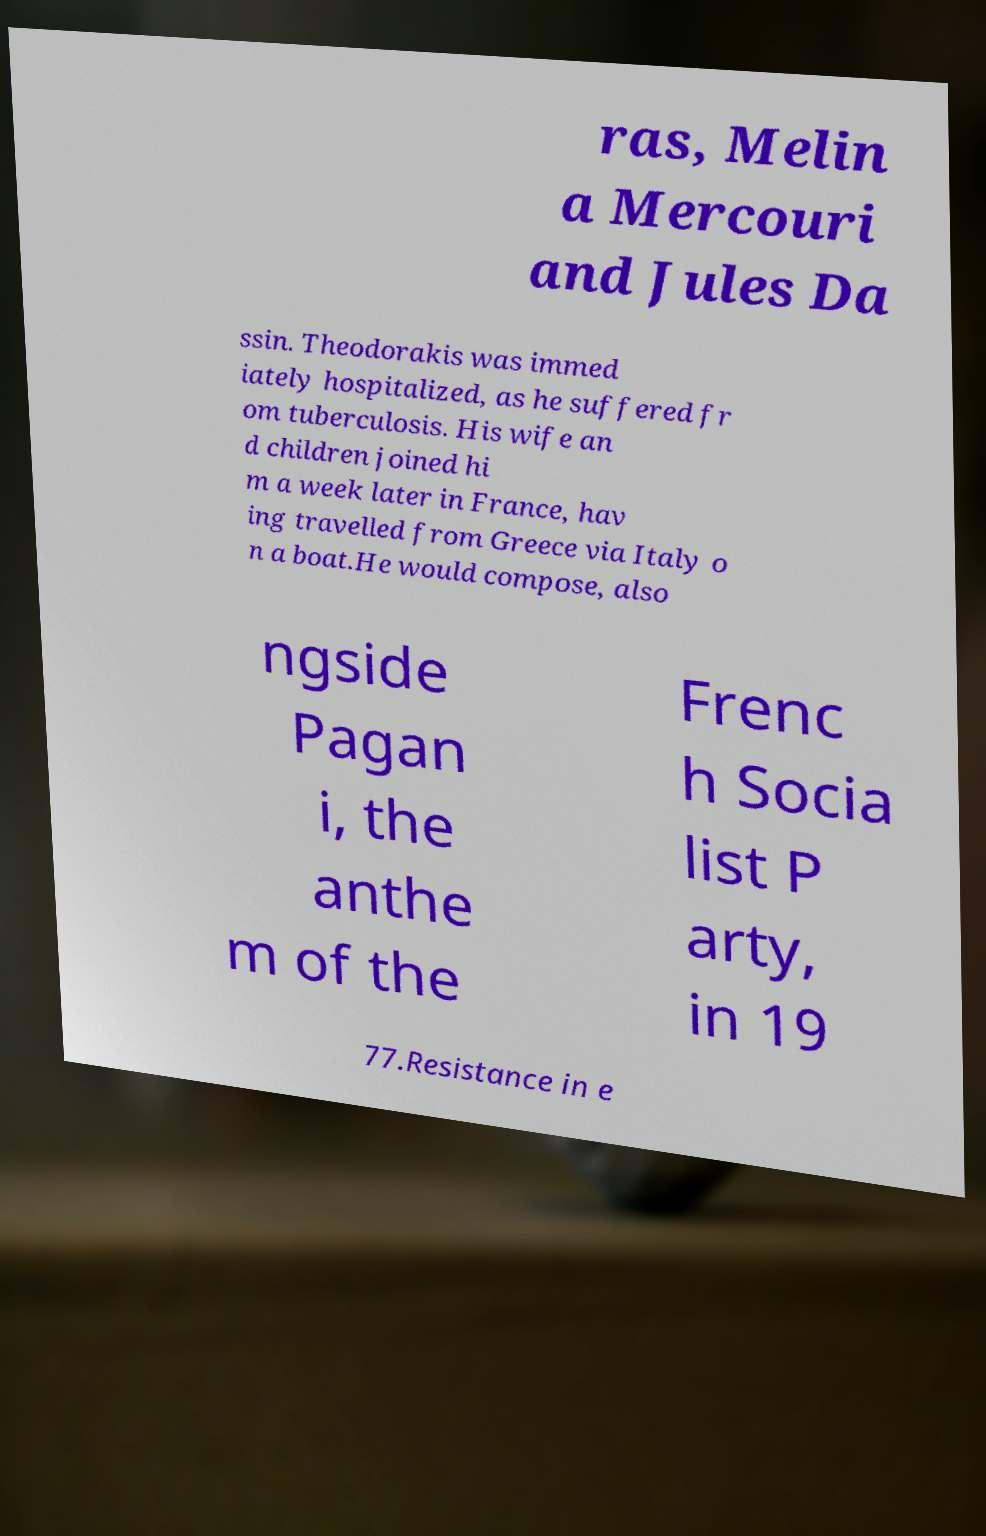Please identify and transcribe the text found in this image. ras, Melin a Mercouri and Jules Da ssin. Theodorakis was immed iately hospitalized, as he suffered fr om tuberculosis. His wife an d children joined hi m a week later in France, hav ing travelled from Greece via Italy o n a boat.He would compose, also ngside Pagan i, the anthe m of the Frenc h Socia list P arty, in 19 77.Resistance in e 